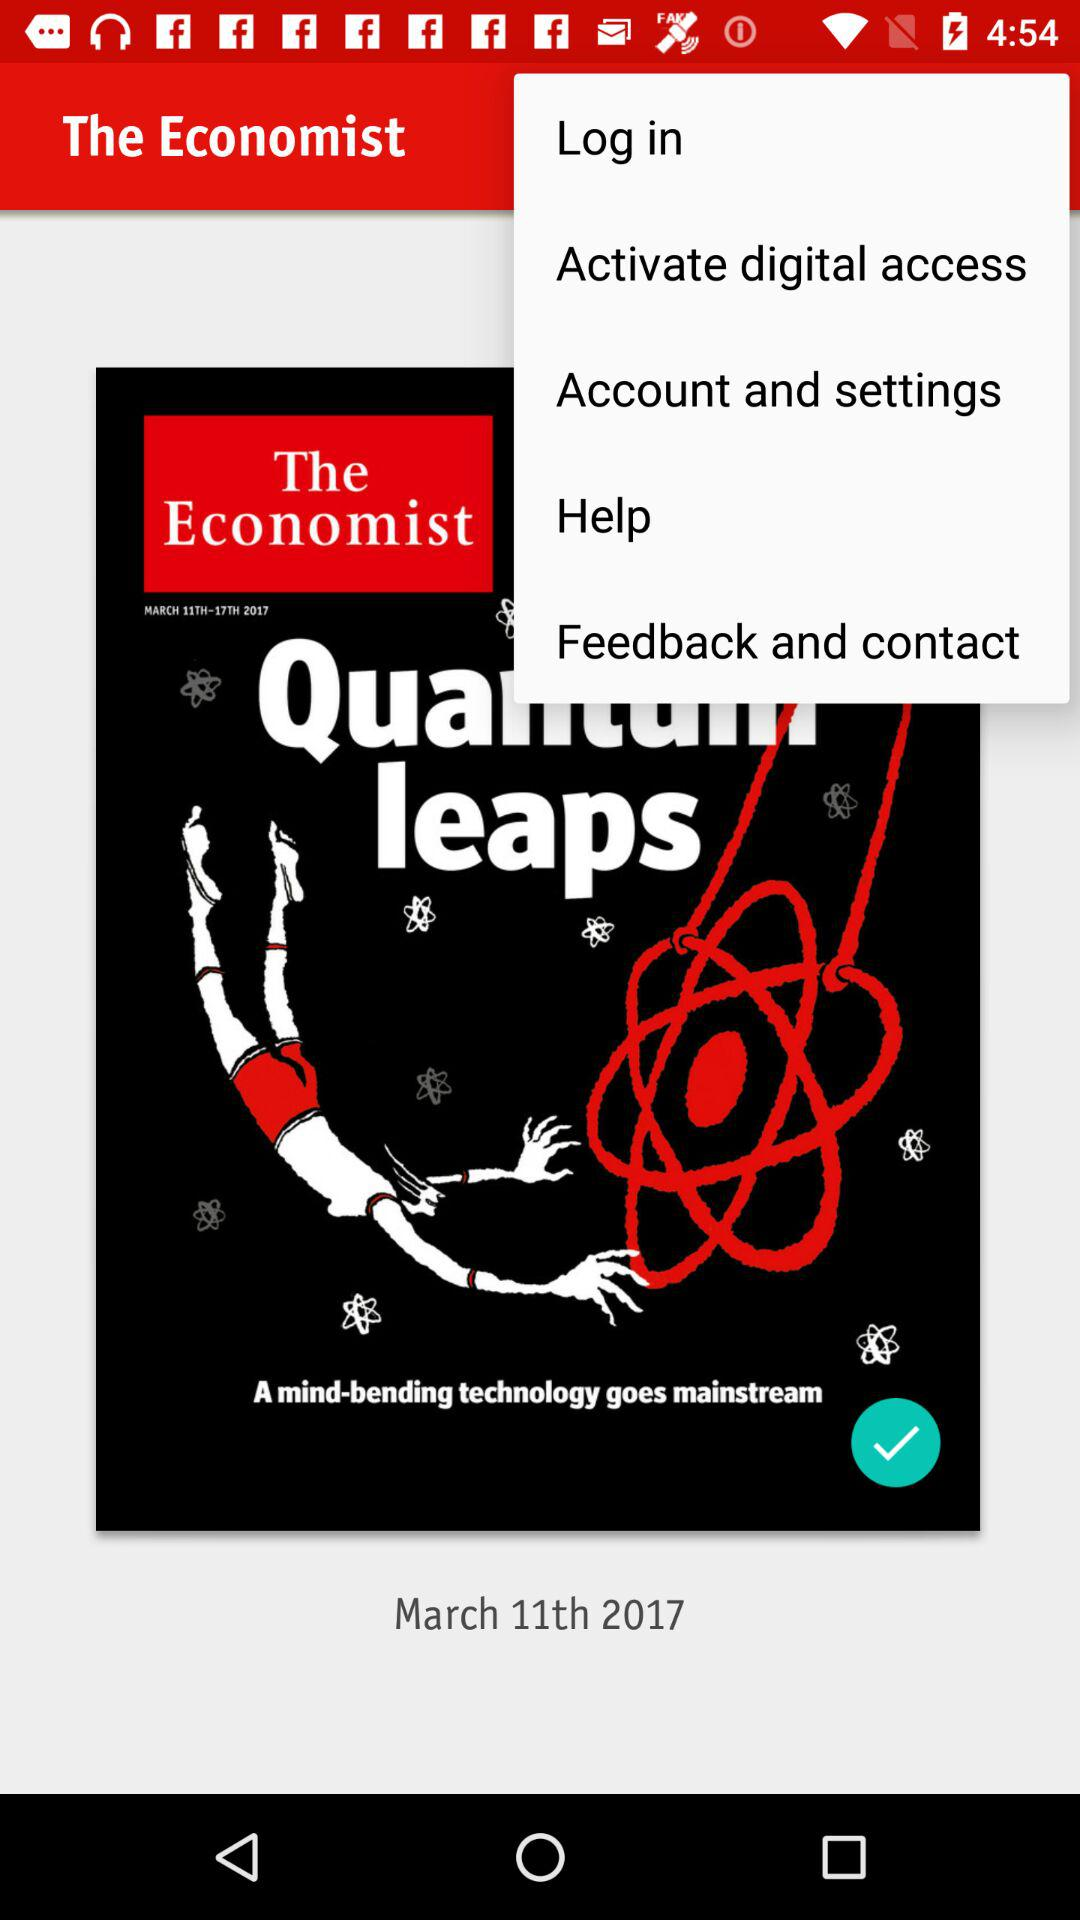What's the date? The date is March 11, 2017. 